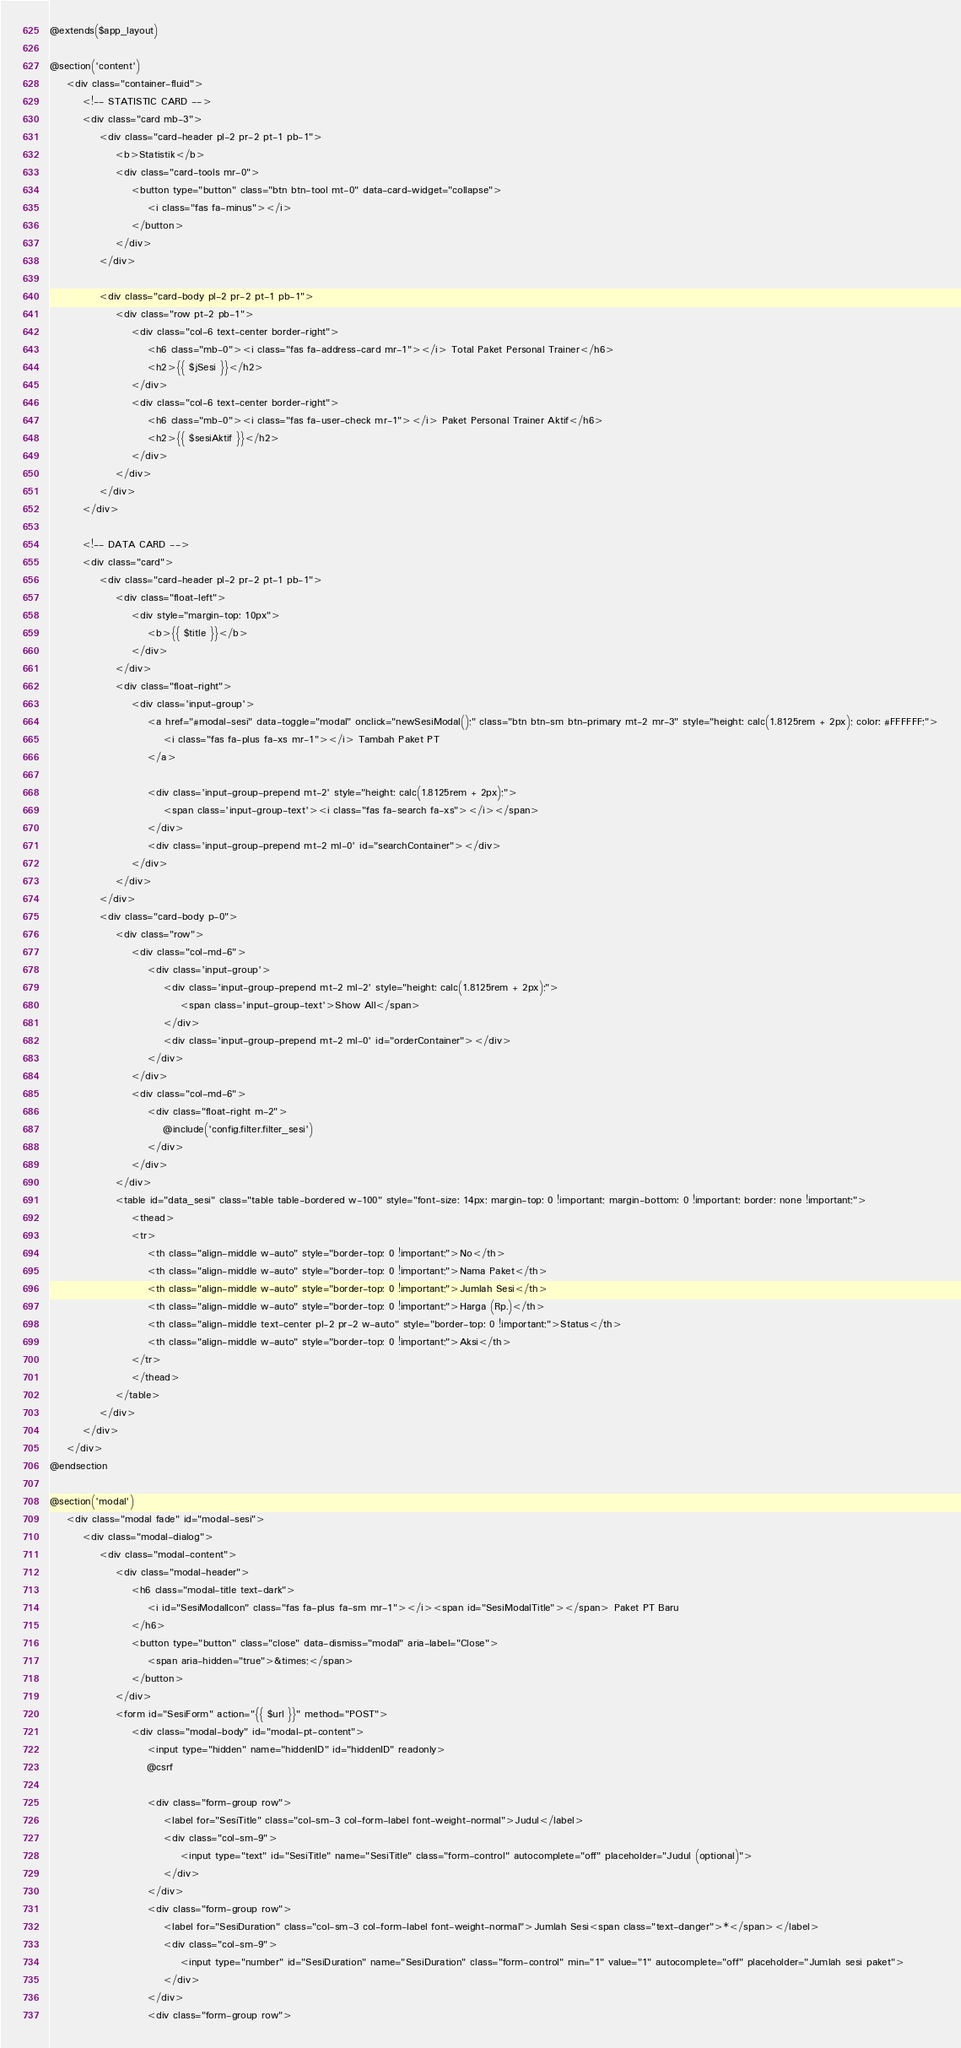<code> <loc_0><loc_0><loc_500><loc_500><_PHP_>@extends($app_layout)

@section('content')
    <div class="container-fluid">
        <!-- STATISTIC CARD -->
        <div class="card mb-3">
            <div class="card-header pl-2 pr-2 pt-1 pb-1">
                <b>Statistik</b>
                <div class="card-tools mr-0">
                    <button type="button" class="btn btn-tool mt-0" data-card-widget="collapse">
                        <i class="fas fa-minus"></i>
                    </button>
                </div>
            </div>

            <div class="card-body pl-2 pr-2 pt-1 pb-1">
                <div class="row pt-2 pb-1">
                    <div class="col-6 text-center border-right">
                        <h6 class="mb-0"><i class="fas fa-address-card mr-1"></i> Total Paket Personal Trainer</h6>
                        <h2>{{ $jSesi }}</h2>
                    </div>
                    <div class="col-6 text-center border-right">
                        <h6 class="mb-0"><i class="fas fa-user-check mr-1"></i> Paket Personal Trainer Aktif</h6>
                        <h2>{{ $sesiAktif }}</h2>
                    </div>
                </div>
            </div>
        </div>

        <!-- DATA CARD -->
        <div class="card">
            <div class="card-header pl-2 pr-2 pt-1 pb-1">
                <div class="float-left">
                    <div style="margin-top: 10px">
                        <b>{{ $title }}</b>
                    </div>
                </div>
                <div class="float-right">
                    <div class='input-group'>
                        <a href="#modal-sesi" data-toggle="modal" onclick="newSesiModal();" class="btn btn-sm btn-primary mt-2 mr-3" style="height: calc(1.8125rem + 2px); color: #FFFFFF;">
                            <i class="fas fa-plus fa-xs mr-1"></i> Tambah Paket PT
                        </a>

                        <div class='input-group-prepend mt-2' style="height: calc(1.8125rem + 2px);">
                            <span class='input-group-text'><i class="fas fa-search fa-xs"></i></span>
                        </div>
                        <div class='input-group-prepend mt-2 ml-0' id="searchContainer"></div>
                    </div>
                </div>
            </div>
            <div class="card-body p-0">
                <div class="row">
                    <div class="col-md-6">
                        <div class='input-group'>
                            <div class='input-group-prepend mt-2 ml-2' style="height: calc(1.8125rem + 2px);">
                                <span class='input-group-text'>Show All</span>
                            </div>
                            <div class='input-group-prepend mt-2 ml-0' id="orderContainer"></div>
                        </div>
                    </div>
                    <div class="col-md-6">
                        <div class="float-right m-2">
                            @include('config.filter.filter_sesi')
                        </div>
                    </div>
                </div>
                <table id="data_sesi" class="table table-bordered w-100" style="font-size: 14px; margin-top: 0 !important; margin-bottom: 0 !important; border: none !important;">
                    <thead>
                    <tr>
                        <th class="align-middle w-auto" style="border-top: 0 !important;">No</th>
                        <th class="align-middle w-auto" style="border-top: 0 !important;">Nama Paket</th>
                        <th class="align-middle w-auto" style="border-top: 0 !important;">Jumlah Sesi</th>
                        <th class="align-middle w-auto" style="border-top: 0 !important;">Harga (Rp.)</th>
                        <th class="align-middle text-center pl-2 pr-2 w-auto" style="border-top: 0 !important;">Status</th>
                        <th class="align-middle w-auto" style="border-top: 0 !important;">Aksi</th>
                    </tr>
                    </thead>
                </table>
            </div>
        </div>
    </div>
@endsection

@section('modal')
    <div class="modal fade" id="modal-sesi">
        <div class="modal-dialog">
            <div class="modal-content">
                <div class="modal-header">
                    <h6 class="modal-title text-dark">
                        <i id="SesiModalIcon" class="fas fa-plus fa-sm mr-1"></i><span id="SesiModalTitle"></span> Paket PT Baru
                    </h6>
                    <button type="button" class="close" data-dismiss="modal" aria-label="Close">
                        <span aria-hidden="true">&times;</span>
                    </button>
                </div>
                <form id="SesiForm" action="{{ $url }}" method="POST">
                    <div class="modal-body" id="modal-pt-content">
                        <input type="hidden" name="hiddenID" id="hiddenID" readonly>
                        @csrf

                        <div class="form-group row">
                            <label for="SesiTitle" class="col-sm-3 col-form-label font-weight-normal">Judul</label>
                            <div class="col-sm-9">
                                <input type="text" id="SesiTitle" name="SesiTitle" class="form-control" autocomplete="off" placeholder="Judul (optional)">
                            </div>
                        </div>
                        <div class="form-group row">
                            <label for="SesiDuration" class="col-sm-3 col-form-label font-weight-normal">Jumlah Sesi<span class="text-danger">*</span></label>
                            <div class="col-sm-9">
                                <input type="number" id="SesiDuration" name="SesiDuration" class="form-control" min="1" value="1" autocomplete="off" placeholder="Jumlah sesi paket">
                            </div>
                        </div>
                        <div class="form-group row"></code> 